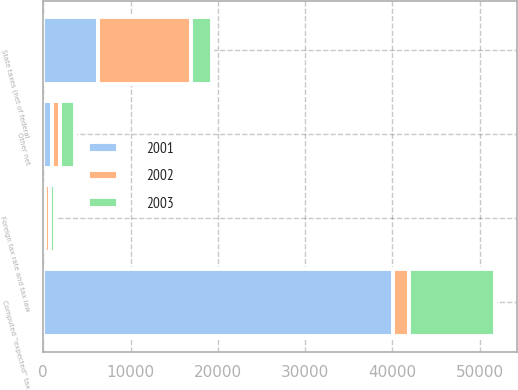Convert chart to OTSL. <chart><loc_0><loc_0><loc_500><loc_500><stacked_bar_chart><ecel><fcel>Computed ''expected'' tax<fcel>State taxes (net of federal<fcel>Foreign tax rate and tax law<fcel>Other net<nl><fcel>2003<fcel>9838<fcel>2432<fcel>598<fcel>1785<nl><fcel>2001<fcel>40082<fcel>6220<fcel>209<fcel>1015<nl><fcel>2002<fcel>1785<fcel>10650<fcel>540<fcel>865<nl></chart> 